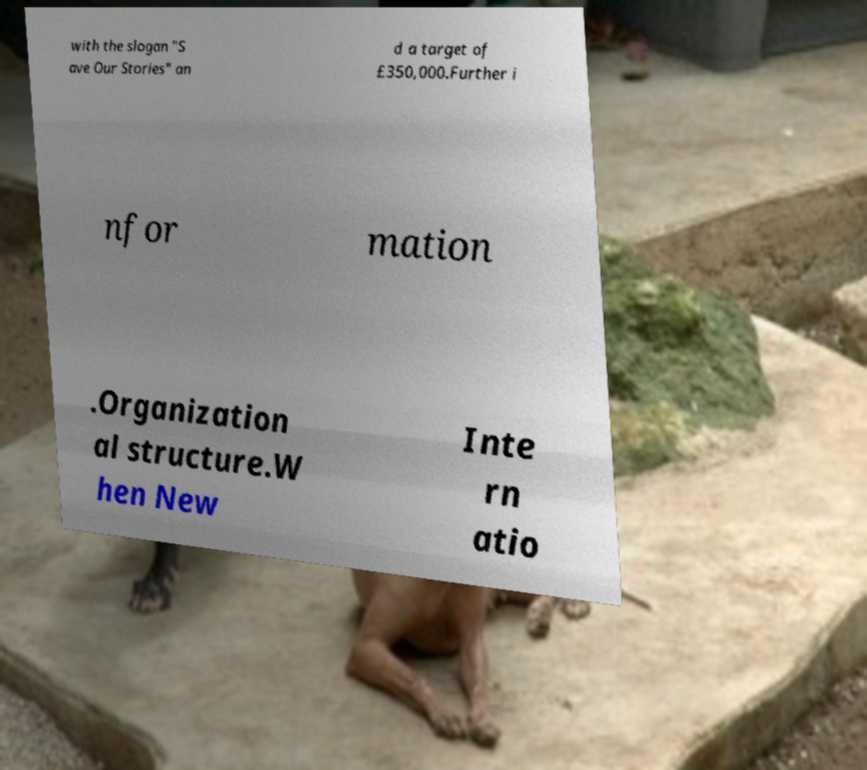Could you extract and type out the text from this image? with the slogan "S ave Our Stories" an d a target of £350,000.Further i nfor mation .Organization al structure.W hen New Inte rn atio 